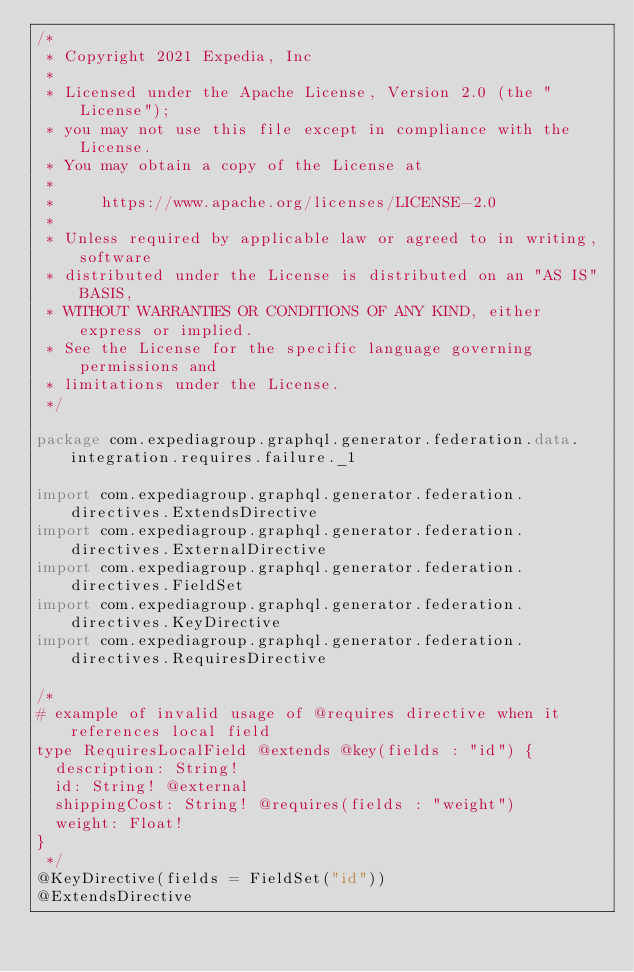<code> <loc_0><loc_0><loc_500><loc_500><_Kotlin_>/*
 * Copyright 2021 Expedia, Inc
 *
 * Licensed under the Apache License, Version 2.0 (the "License");
 * you may not use this file except in compliance with the License.
 * You may obtain a copy of the License at
 *
 *     https://www.apache.org/licenses/LICENSE-2.0
 *
 * Unless required by applicable law or agreed to in writing, software
 * distributed under the License is distributed on an "AS IS" BASIS,
 * WITHOUT WARRANTIES OR CONDITIONS OF ANY KIND, either express or implied.
 * See the License for the specific language governing permissions and
 * limitations under the License.
 */

package com.expediagroup.graphql.generator.federation.data.integration.requires.failure._1

import com.expediagroup.graphql.generator.federation.directives.ExtendsDirective
import com.expediagroup.graphql.generator.federation.directives.ExternalDirective
import com.expediagroup.graphql.generator.federation.directives.FieldSet
import com.expediagroup.graphql.generator.federation.directives.KeyDirective
import com.expediagroup.graphql.generator.federation.directives.RequiresDirective

/*
# example of invalid usage of @requires directive when it references local field
type RequiresLocalField @extends @key(fields : "id") {
  description: String!
  id: String! @external
  shippingCost: String! @requires(fields : "weight")
  weight: Float!
}
 */
@KeyDirective(fields = FieldSet("id"))
@ExtendsDirective</code> 